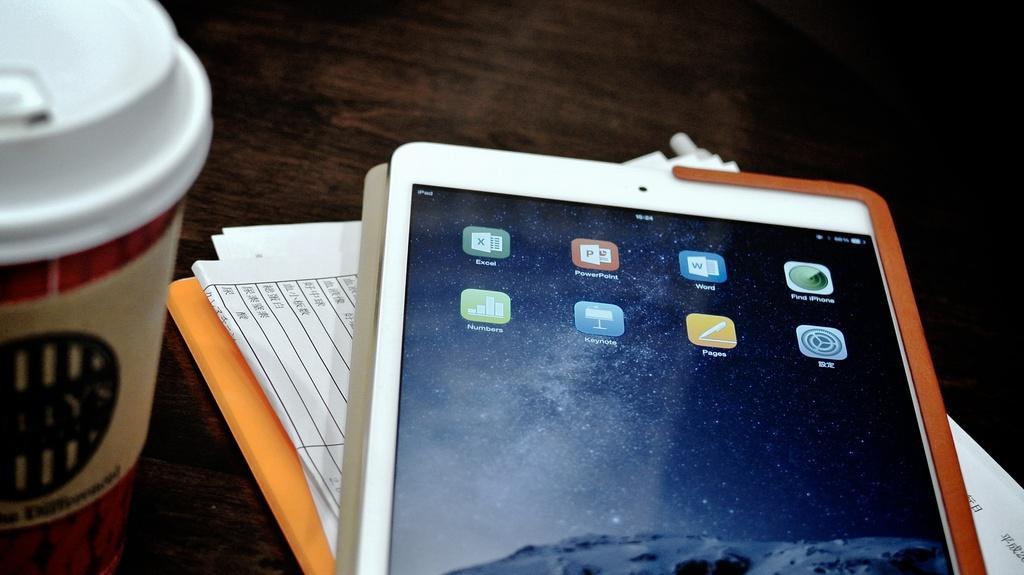Describe this image in one or two sentences. In this image I can see a mobile and few papers, a glass on the table and the table is in brown color. 